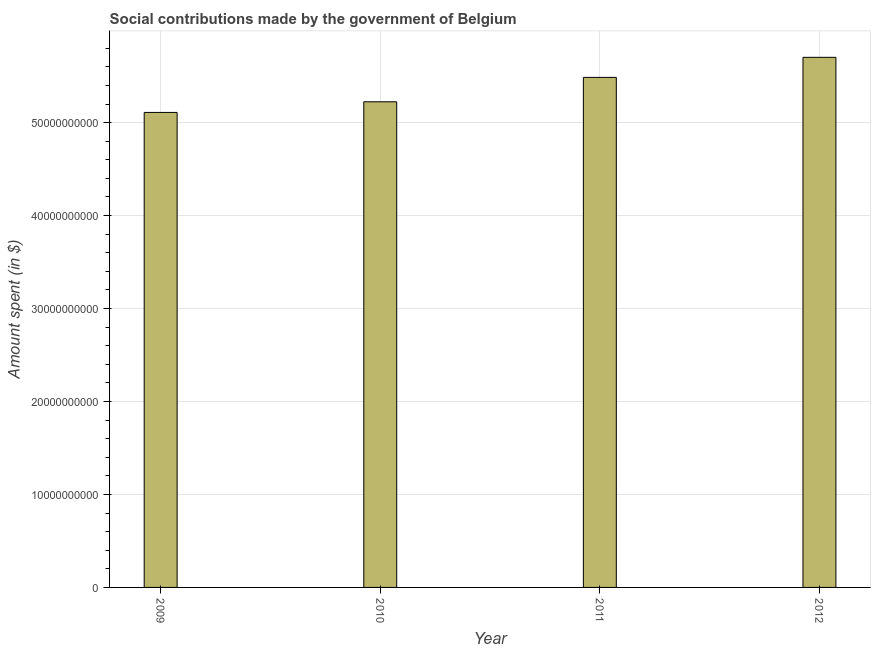Does the graph contain any zero values?
Provide a succinct answer. No. Does the graph contain grids?
Your answer should be very brief. Yes. What is the title of the graph?
Your answer should be very brief. Social contributions made by the government of Belgium. What is the label or title of the Y-axis?
Make the answer very short. Amount spent (in $). What is the amount spent in making social contributions in 2009?
Give a very brief answer. 5.11e+1. Across all years, what is the maximum amount spent in making social contributions?
Your response must be concise. 5.70e+1. Across all years, what is the minimum amount spent in making social contributions?
Ensure brevity in your answer.  5.11e+1. In which year was the amount spent in making social contributions maximum?
Your answer should be very brief. 2012. In which year was the amount spent in making social contributions minimum?
Give a very brief answer. 2009. What is the sum of the amount spent in making social contributions?
Your response must be concise. 2.15e+11. What is the difference between the amount spent in making social contributions in 2009 and 2011?
Provide a succinct answer. -3.77e+09. What is the average amount spent in making social contributions per year?
Make the answer very short. 5.38e+1. What is the median amount spent in making social contributions?
Provide a short and direct response. 5.36e+1. Do a majority of the years between 2009 and 2012 (inclusive) have amount spent in making social contributions greater than 26000000000 $?
Give a very brief answer. Yes. Is the amount spent in making social contributions in 2009 less than that in 2010?
Make the answer very short. Yes. What is the difference between the highest and the second highest amount spent in making social contributions?
Give a very brief answer. 2.16e+09. What is the difference between the highest and the lowest amount spent in making social contributions?
Offer a very short reply. 5.93e+09. How many bars are there?
Make the answer very short. 4. Are all the bars in the graph horizontal?
Offer a very short reply. No. How many years are there in the graph?
Your response must be concise. 4. What is the difference between two consecutive major ticks on the Y-axis?
Offer a terse response. 1.00e+1. What is the Amount spent (in $) in 2009?
Your answer should be very brief. 5.11e+1. What is the Amount spent (in $) of 2010?
Your response must be concise. 5.22e+1. What is the Amount spent (in $) of 2011?
Keep it short and to the point. 5.49e+1. What is the Amount spent (in $) in 2012?
Ensure brevity in your answer.  5.70e+1. What is the difference between the Amount spent (in $) in 2009 and 2010?
Your response must be concise. -1.14e+09. What is the difference between the Amount spent (in $) in 2009 and 2011?
Provide a succinct answer. -3.77e+09. What is the difference between the Amount spent (in $) in 2009 and 2012?
Keep it short and to the point. -5.93e+09. What is the difference between the Amount spent (in $) in 2010 and 2011?
Provide a succinct answer. -2.62e+09. What is the difference between the Amount spent (in $) in 2010 and 2012?
Provide a succinct answer. -4.78e+09. What is the difference between the Amount spent (in $) in 2011 and 2012?
Give a very brief answer. -2.16e+09. What is the ratio of the Amount spent (in $) in 2009 to that in 2010?
Keep it short and to the point. 0.98. What is the ratio of the Amount spent (in $) in 2009 to that in 2011?
Ensure brevity in your answer.  0.93. What is the ratio of the Amount spent (in $) in 2009 to that in 2012?
Your answer should be very brief. 0.9. What is the ratio of the Amount spent (in $) in 2010 to that in 2011?
Your answer should be compact. 0.95. What is the ratio of the Amount spent (in $) in 2010 to that in 2012?
Your response must be concise. 0.92. What is the ratio of the Amount spent (in $) in 2011 to that in 2012?
Your answer should be compact. 0.96. 